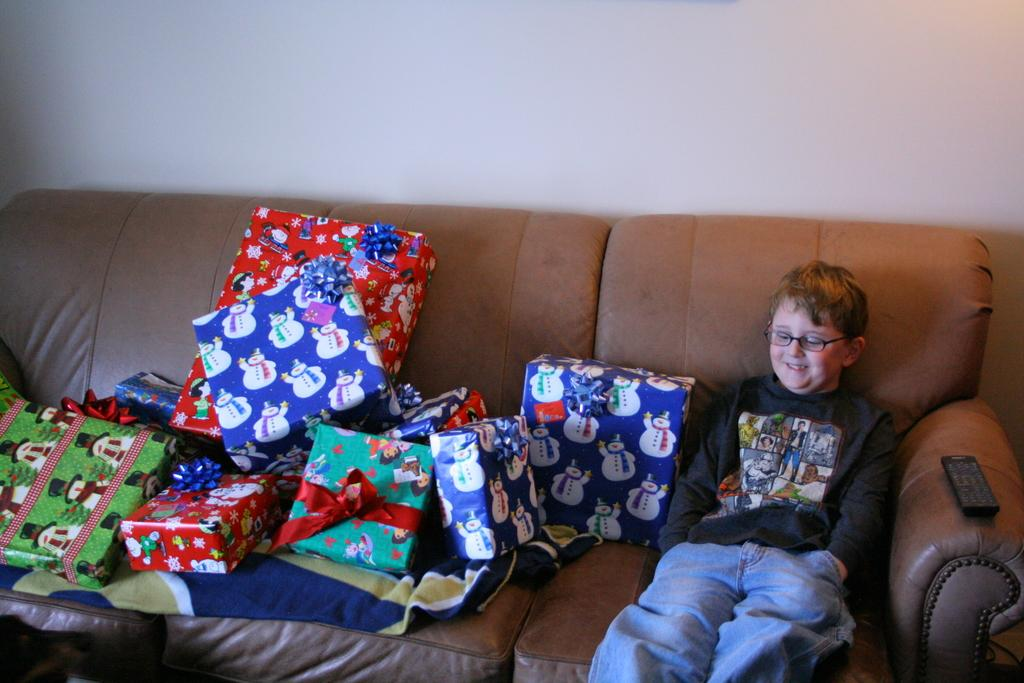What is the person in the image doing? There is a person sitting on the sofa in the image. What else can be seen on the sofa besides the person? There are gifts and a remote placed on the sofa. What is visible behind the sofa? There is a wall behind the sofa. What type of rice is being served on the sofa? There is no rice present in the image; it only features a person, gifts, and a remote on the sofa. 